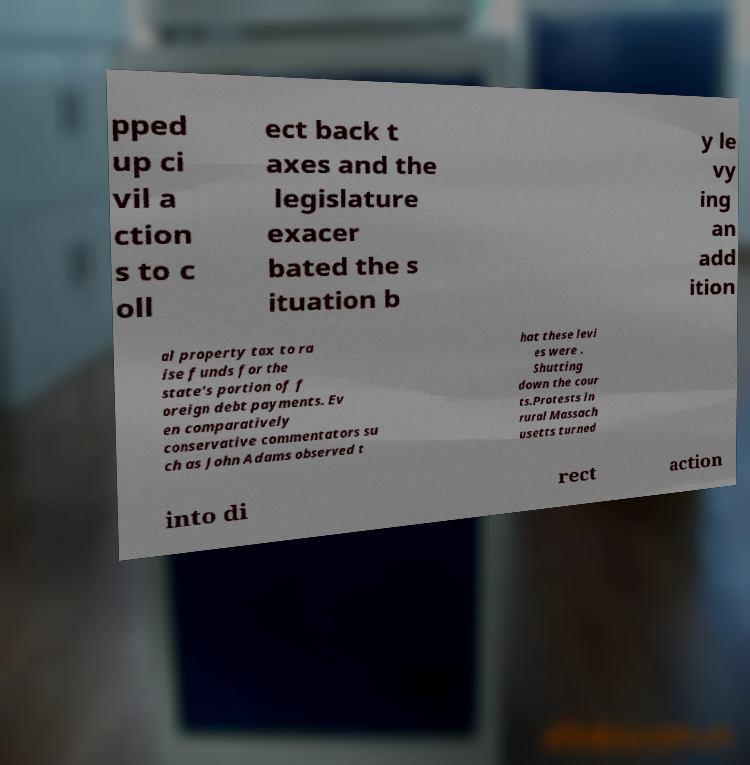Can you read and provide the text displayed in the image?This photo seems to have some interesting text. Can you extract and type it out for me? pped up ci vil a ction s to c oll ect back t axes and the legislature exacer bated the s ituation b y le vy ing an add ition al property tax to ra ise funds for the state's portion of f oreign debt payments. Ev en comparatively conservative commentators su ch as John Adams observed t hat these levi es were . Shutting down the cour ts.Protests in rural Massach usetts turned into di rect action 